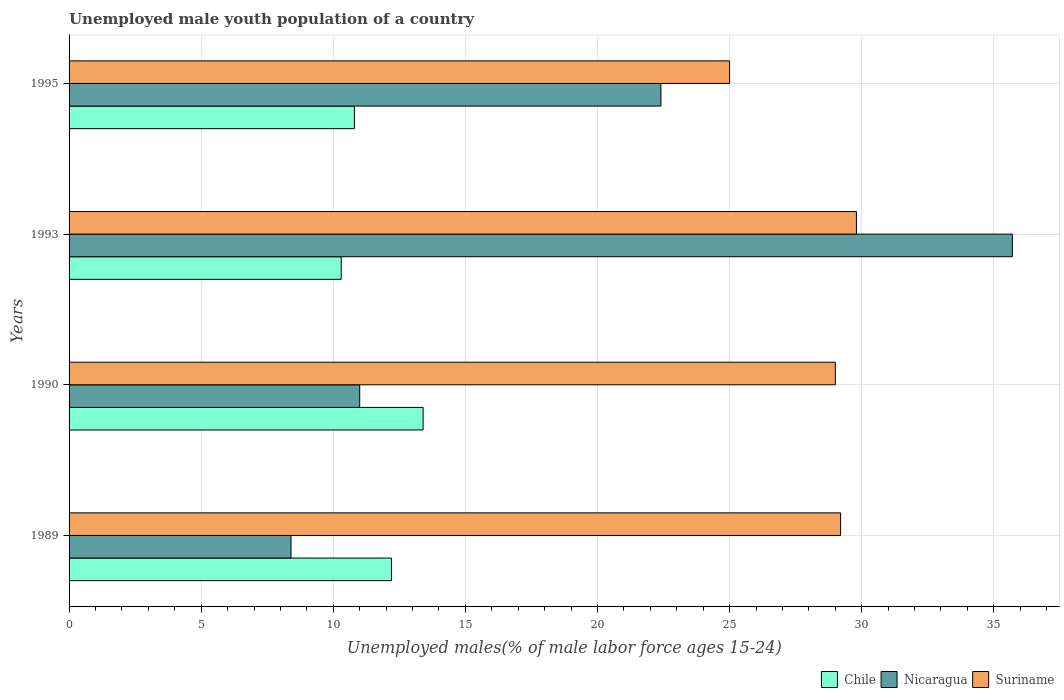How many different coloured bars are there?
Offer a very short reply. 3. Are the number of bars per tick equal to the number of legend labels?
Provide a succinct answer. Yes. How many bars are there on the 3rd tick from the top?
Give a very brief answer. 3. In how many cases, is the number of bars for a given year not equal to the number of legend labels?
Your response must be concise. 0. What is the percentage of unemployed male youth population in Chile in 1993?
Give a very brief answer. 10.3. Across all years, what is the maximum percentage of unemployed male youth population in Suriname?
Your response must be concise. 29.8. Across all years, what is the minimum percentage of unemployed male youth population in Nicaragua?
Offer a very short reply. 8.4. What is the total percentage of unemployed male youth population in Suriname in the graph?
Make the answer very short. 113. What is the difference between the percentage of unemployed male youth population in Nicaragua in 1989 and that in 1995?
Ensure brevity in your answer.  -14. What is the difference between the percentage of unemployed male youth population in Suriname in 1989 and the percentage of unemployed male youth population in Nicaragua in 1995?
Your answer should be very brief. 6.8. What is the average percentage of unemployed male youth population in Nicaragua per year?
Offer a terse response. 19.38. In the year 1993, what is the difference between the percentage of unemployed male youth population in Chile and percentage of unemployed male youth population in Suriname?
Give a very brief answer. -19.5. What is the ratio of the percentage of unemployed male youth population in Chile in 1989 to that in 1995?
Provide a short and direct response. 1.13. What is the difference between the highest and the second highest percentage of unemployed male youth population in Chile?
Your answer should be compact. 1.2. What is the difference between the highest and the lowest percentage of unemployed male youth population in Nicaragua?
Make the answer very short. 27.3. What does the 2nd bar from the top in 1989 represents?
Provide a short and direct response. Nicaragua. What does the 2nd bar from the bottom in 1993 represents?
Provide a short and direct response. Nicaragua. Is it the case that in every year, the sum of the percentage of unemployed male youth population in Nicaragua and percentage of unemployed male youth population in Suriname is greater than the percentage of unemployed male youth population in Chile?
Your answer should be compact. Yes. Are all the bars in the graph horizontal?
Provide a short and direct response. Yes. How many years are there in the graph?
Your answer should be very brief. 4. Does the graph contain grids?
Make the answer very short. Yes. How many legend labels are there?
Your response must be concise. 3. How are the legend labels stacked?
Offer a terse response. Horizontal. What is the title of the graph?
Offer a very short reply. Unemployed male youth population of a country. What is the label or title of the X-axis?
Provide a short and direct response. Unemployed males(% of male labor force ages 15-24). What is the Unemployed males(% of male labor force ages 15-24) in Chile in 1989?
Give a very brief answer. 12.2. What is the Unemployed males(% of male labor force ages 15-24) in Nicaragua in 1989?
Provide a succinct answer. 8.4. What is the Unemployed males(% of male labor force ages 15-24) of Suriname in 1989?
Provide a short and direct response. 29.2. What is the Unemployed males(% of male labor force ages 15-24) in Chile in 1990?
Your response must be concise. 13.4. What is the Unemployed males(% of male labor force ages 15-24) of Chile in 1993?
Keep it short and to the point. 10.3. What is the Unemployed males(% of male labor force ages 15-24) in Nicaragua in 1993?
Your answer should be very brief. 35.7. What is the Unemployed males(% of male labor force ages 15-24) in Suriname in 1993?
Make the answer very short. 29.8. What is the Unemployed males(% of male labor force ages 15-24) of Chile in 1995?
Keep it short and to the point. 10.8. What is the Unemployed males(% of male labor force ages 15-24) of Nicaragua in 1995?
Your answer should be very brief. 22.4. What is the Unemployed males(% of male labor force ages 15-24) of Suriname in 1995?
Keep it short and to the point. 25. Across all years, what is the maximum Unemployed males(% of male labor force ages 15-24) in Chile?
Your answer should be very brief. 13.4. Across all years, what is the maximum Unemployed males(% of male labor force ages 15-24) of Nicaragua?
Keep it short and to the point. 35.7. Across all years, what is the maximum Unemployed males(% of male labor force ages 15-24) in Suriname?
Ensure brevity in your answer.  29.8. Across all years, what is the minimum Unemployed males(% of male labor force ages 15-24) in Chile?
Offer a terse response. 10.3. Across all years, what is the minimum Unemployed males(% of male labor force ages 15-24) in Nicaragua?
Make the answer very short. 8.4. What is the total Unemployed males(% of male labor force ages 15-24) in Chile in the graph?
Provide a short and direct response. 46.7. What is the total Unemployed males(% of male labor force ages 15-24) of Nicaragua in the graph?
Your answer should be compact. 77.5. What is the total Unemployed males(% of male labor force ages 15-24) of Suriname in the graph?
Your answer should be very brief. 113. What is the difference between the Unemployed males(% of male labor force ages 15-24) of Chile in 1989 and that in 1990?
Offer a terse response. -1.2. What is the difference between the Unemployed males(% of male labor force ages 15-24) of Nicaragua in 1989 and that in 1990?
Provide a succinct answer. -2.6. What is the difference between the Unemployed males(% of male labor force ages 15-24) in Nicaragua in 1989 and that in 1993?
Your answer should be very brief. -27.3. What is the difference between the Unemployed males(% of male labor force ages 15-24) of Suriname in 1989 and that in 1993?
Keep it short and to the point. -0.6. What is the difference between the Unemployed males(% of male labor force ages 15-24) of Suriname in 1989 and that in 1995?
Give a very brief answer. 4.2. What is the difference between the Unemployed males(% of male labor force ages 15-24) of Nicaragua in 1990 and that in 1993?
Make the answer very short. -24.7. What is the difference between the Unemployed males(% of male labor force ages 15-24) in Chile in 1990 and that in 1995?
Provide a succinct answer. 2.6. What is the difference between the Unemployed males(% of male labor force ages 15-24) in Nicaragua in 1993 and that in 1995?
Keep it short and to the point. 13.3. What is the difference between the Unemployed males(% of male labor force ages 15-24) of Suriname in 1993 and that in 1995?
Ensure brevity in your answer.  4.8. What is the difference between the Unemployed males(% of male labor force ages 15-24) in Chile in 1989 and the Unemployed males(% of male labor force ages 15-24) in Nicaragua in 1990?
Your response must be concise. 1.2. What is the difference between the Unemployed males(% of male labor force ages 15-24) of Chile in 1989 and the Unemployed males(% of male labor force ages 15-24) of Suriname in 1990?
Offer a very short reply. -16.8. What is the difference between the Unemployed males(% of male labor force ages 15-24) of Nicaragua in 1989 and the Unemployed males(% of male labor force ages 15-24) of Suriname in 1990?
Keep it short and to the point. -20.6. What is the difference between the Unemployed males(% of male labor force ages 15-24) of Chile in 1989 and the Unemployed males(% of male labor force ages 15-24) of Nicaragua in 1993?
Offer a very short reply. -23.5. What is the difference between the Unemployed males(% of male labor force ages 15-24) of Chile in 1989 and the Unemployed males(% of male labor force ages 15-24) of Suriname in 1993?
Provide a short and direct response. -17.6. What is the difference between the Unemployed males(% of male labor force ages 15-24) in Nicaragua in 1989 and the Unemployed males(% of male labor force ages 15-24) in Suriname in 1993?
Provide a short and direct response. -21.4. What is the difference between the Unemployed males(% of male labor force ages 15-24) in Chile in 1989 and the Unemployed males(% of male labor force ages 15-24) in Suriname in 1995?
Your answer should be compact. -12.8. What is the difference between the Unemployed males(% of male labor force ages 15-24) in Nicaragua in 1989 and the Unemployed males(% of male labor force ages 15-24) in Suriname in 1995?
Make the answer very short. -16.6. What is the difference between the Unemployed males(% of male labor force ages 15-24) of Chile in 1990 and the Unemployed males(% of male labor force ages 15-24) of Nicaragua in 1993?
Keep it short and to the point. -22.3. What is the difference between the Unemployed males(% of male labor force ages 15-24) of Chile in 1990 and the Unemployed males(% of male labor force ages 15-24) of Suriname in 1993?
Your answer should be compact. -16.4. What is the difference between the Unemployed males(% of male labor force ages 15-24) in Nicaragua in 1990 and the Unemployed males(% of male labor force ages 15-24) in Suriname in 1993?
Ensure brevity in your answer.  -18.8. What is the difference between the Unemployed males(% of male labor force ages 15-24) in Chile in 1990 and the Unemployed males(% of male labor force ages 15-24) in Nicaragua in 1995?
Ensure brevity in your answer.  -9. What is the difference between the Unemployed males(% of male labor force ages 15-24) in Nicaragua in 1990 and the Unemployed males(% of male labor force ages 15-24) in Suriname in 1995?
Keep it short and to the point. -14. What is the difference between the Unemployed males(% of male labor force ages 15-24) in Chile in 1993 and the Unemployed males(% of male labor force ages 15-24) in Suriname in 1995?
Make the answer very short. -14.7. What is the average Unemployed males(% of male labor force ages 15-24) of Chile per year?
Make the answer very short. 11.68. What is the average Unemployed males(% of male labor force ages 15-24) in Nicaragua per year?
Your answer should be very brief. 19.38. What is the average Unemployed males(% of male labor force ages 15-24) of Suriname per year?
Make the answer very short. 28.25. In the year 1989, what is the difference between the Unemployed males(% of male labor force ages 15-24) in Nicaragua and Unemployed males(% of male labor force ages 15-24) in Suriname?
Provide a succinct answer. -20.8. In the year 1990, what is the difference between the Unemployed males(% of male labor force ages 15-24) in Chile and Unemployed males(% of male labor force ages 15-24) in Suriname?
Keep it short and to the point. -15.6. In the year 1990, what is the difference between the Unemployed males(% of male labor force ages 15-24) of Nicaragua and Unemployed males(% of male labor force ages 15-24) of Suriname?
Your answer should be compact. -18. In the year 1993, what is the difference between the Unemployed males(% of male labor force ages 15-24) in Chile and Unemployed males(% of male labor force ages 15-24) in Nicaragua?
Keep it short and to the point. -25.4. In the year 1993, what is the difference between the Unemployed males(% of male labor force ages 15-24) of Chile and Unemployed males(% of male labor force ages 15-24) of Suriname?
Your response must be concise. -19.5. In the year 1995, what is the difference between the Unemployed males(% of male labor force ages 15-24) in Chile and Unemployed males(% of male labor force ages 15-24) in Suriname?
Offer a very short reply. -14.2. What is the ratio of the Unemployed males(% of male labor force ages 15-24) in Chile in 1989 to that in 1990?
Your answer should be compact. 0.91. What is the ratio of the Unemployed males(% of male labor force ages 15-24) of Nicaragua in 1989 to that in 1990?
Keep it short and to the point. 0.76. What is the ratio of the Unemployed males(% of male labor force ages 15-24) of Suriname in 1989 to that in 1990?
Provide a short and direct response. 1.01. What is the ratio of the Unemployed males(% of male labor force ages 15-24) of Chile in 1989 to that in 1993?
Keep it short and to the point. 1.18. What is the ratio of the Unemployed males(% of male labor force ages 15-24) in Nicaragua in 1989 to that in 1993?
Your answer should be compact. 0.24. What is the ratio of the Unemployed males(% of male labor force ages 15-24) in Suriname in 1989 to that in 1993?
Your answer should be compact. 0.98. What is the ratio of the Unemployed males(% of male labor force ages 15-24) of Chile in 1989 to that in 1995?
Keep it short and to the point. 1.13. What is the ratio of the Unemployed males(% of male labor force ages 15-24) of Suriname in 1989 to that in 1995?
Offer a terse response. 1.17. What is the ratio of the Unemployed males(% of male labor force ages 15-24) in Chile in 1990 to that in 1993?
Give a very brief answer. 1.3. What is the ratio of the Unemployed males(% of male labor force ages 15-24) of Nicaragua in 1990 to that in 1993?
Your answer should be very brief. 0.31. What is the ratio of the Unemployed males(% of male labor force ages 15-24) of Suriname in 1990 to that in 1993?
Keep it short and to the point. 0.97. What is the ratio of the Unemployed males(% of male labor force ages 15-24) of Chile in 1990 to that in 1995?
Provide a short and direct response. 1.24. What is the ratio of the Unemployed males(% of male labor force ages 15-24) of Nicaragua in 1990 to that in 1995?
Provide a short and direct response. 0.49. What is the ratio of the Unemployed males(% of male labor force ages 15-24) in Suriname in 1990 to that in 1995?
Your response must be concise. 1.16. What is the ratio of the Unemployed males(% of male labor force ages 15-24) in Chile in 1993 to that in 1995?
Give a very brief answer. 0.95. What is the ratio of the Unemployed males(% of male labor force ages 15-24) of Nicaragua in 1993 to that in 1995?
Provide a short and direct response. 1.59. What is the ratio of the Unemployed males(% of male labor force ages 15-24) in Suriname in 1993 to that in 1995?
Ensure brevity in your answer.  1.19. What is the difference between the highest and the second highest Unemployed males(% of male labor force ages 15-24) of Chile?
Provide a succinct answer. 1.2. What is the difference between the highest and the lowest Unemployed males(% of male labor force ages 15-24) in Nicaragua?
Keep it short and to the point. 27.3. What is the difference between the highest and the lowest Unemployed males(% of male labor force ages 15-24) in Suriname?
Your answer should be compact. 4.8. 